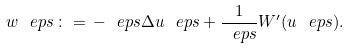<formula> <loc_0><loc_0><loc_500><loc_500>w _ { \ } e p s \, \colon = \, - \ e p s \Delta u _ { \ } e p s + \frac { 1 } { \ e p s } W ^ { \prime } ( u _ { \ } e p s ) .</formula> 